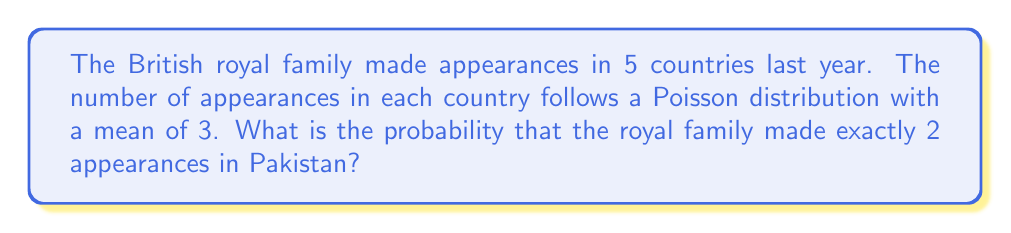Solve this math problem. To solve this problem, we'll use the Poisson probability mass function:

$$P(X = k) = \frac{e^{-\lambda} \lambda^k}{k!}$$

Where:
$\lambda$ = mean number of appearances (3)
$k$ = number of appearances we're interested in (2)
$e$ = Euler's number (approximately 2.71828)

Steps:
1) Substitute the values into the formula:

   $$P(X = 2) = \frac{e^{-3} 3^2}{2!}$$

2) Simplify the numerator:
   $$P(X = 2) = \frac{e^{-3} \times 9}{2}$$

3) Calculate $e^{-3}$:
   $$e^{-3} \approx 0.0497871$$

4) Multiply the numerator:
   $$P(X = 2) = \frac{0.0497871 \times 9}{2}$$

5) Perform the final calculation:
   $$P(X = 2) = \frac{0.4480839}{2} = 0.2240420$$

Therefore, the probability of exactly 2 royal family appearances in Pakistan is approximately 0.2240 or 22.40%.
Answer: 0.2240 